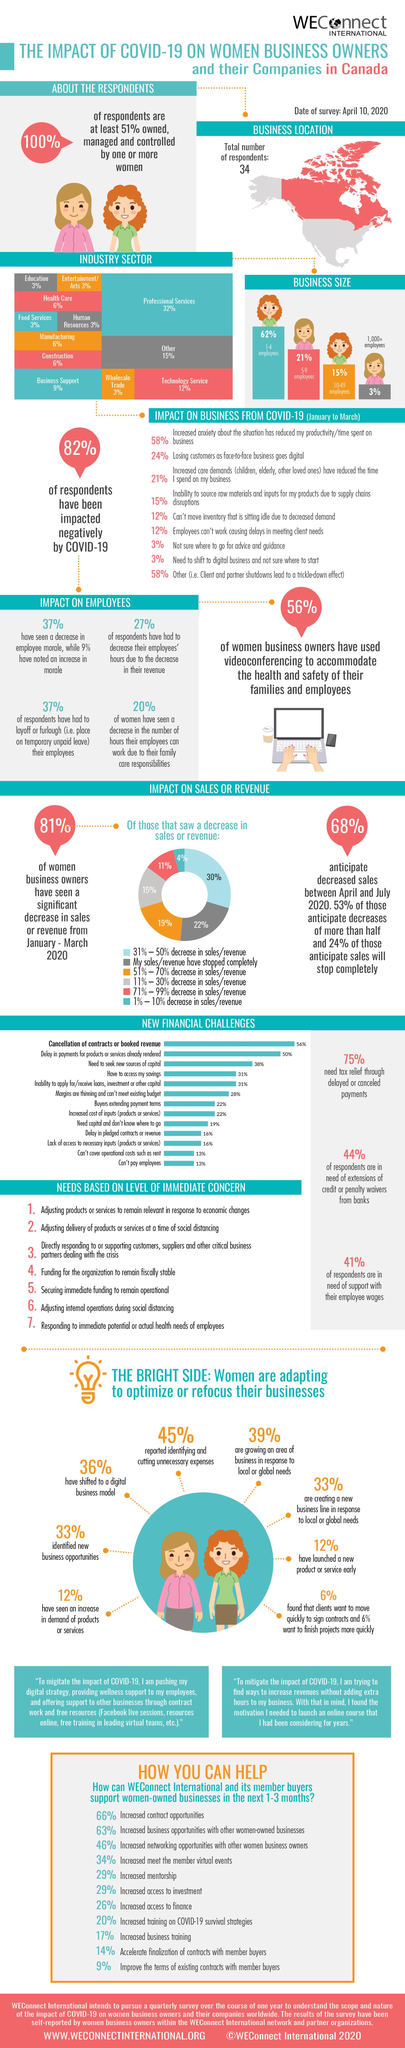Give some essential details in this illustration. According to the pie chart, 11% of respondents anticipate a decrease in sales/revenue between 71% and 99%. According to the survey results, 19% of respondents reported a decrease in sales/revenue of 51-70%. According to the information available, a large majority, or approximately 83%, of businesses have 1-9 employees. The biggest financial challenge for a company is the possibility of cancellations of contracts or booked revenue. Sixty-nine percent of women have shifted to a digital business model and have identified new business opportunities. 